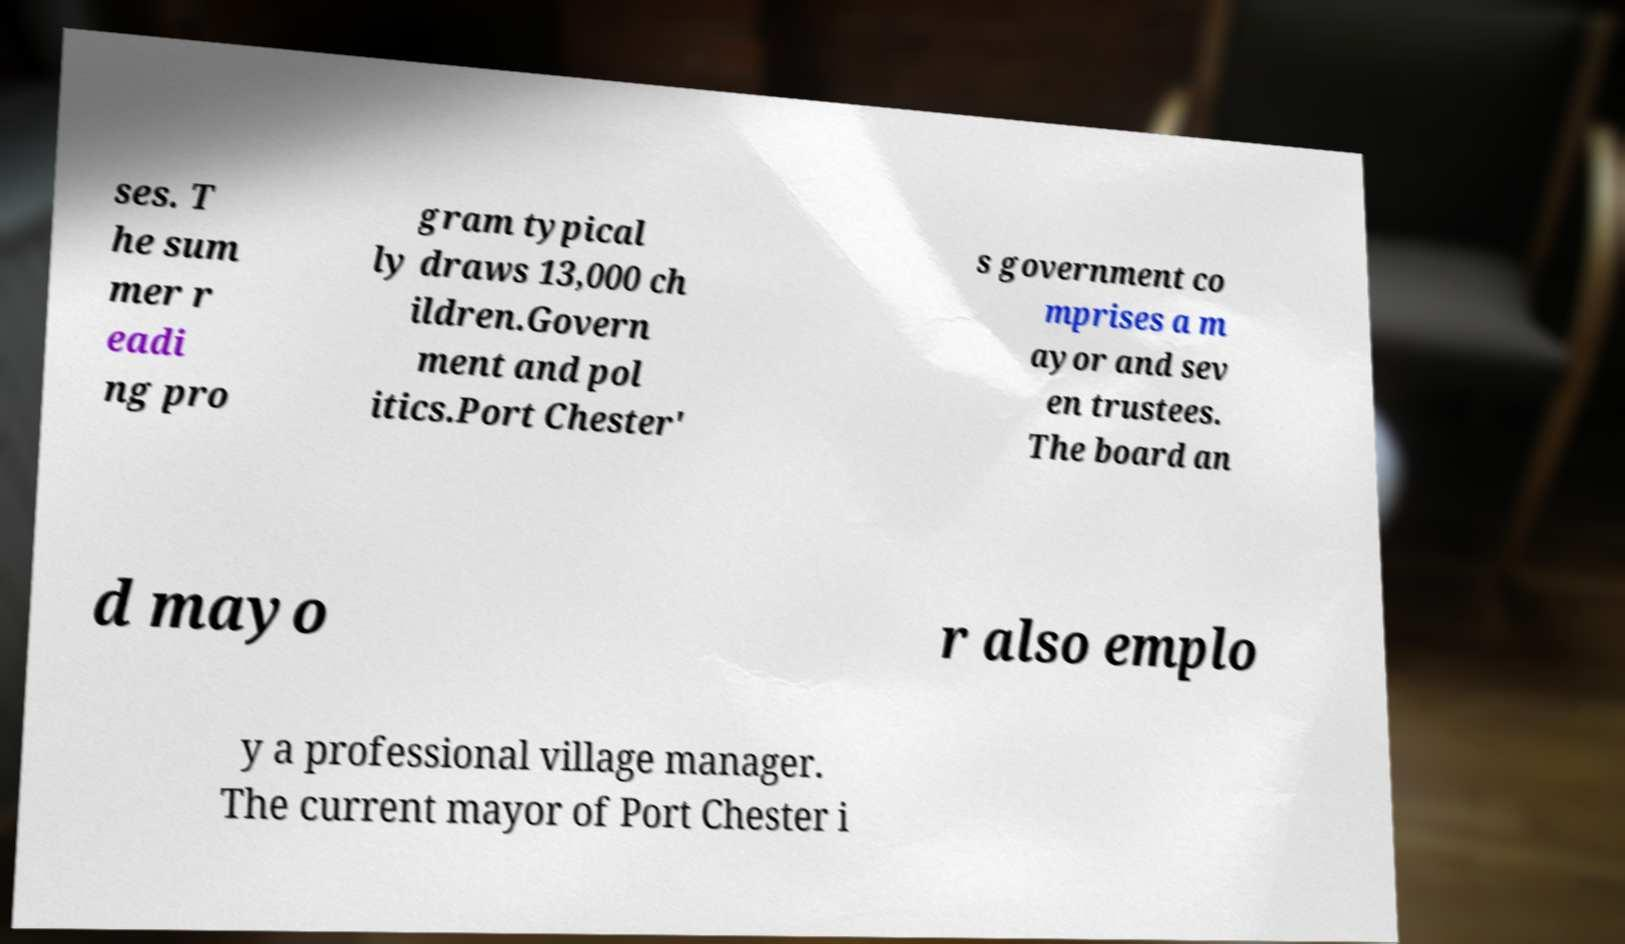For documentation purposes, I need the text within this image transcribed. Could you provide that? ses. T he sum mer r eadi ng pro gram typical ly draws 13,000 ch ildren.Govern ment and pol itics.Port Chester' s government co mprises a m ayor and sev en trustees. The board an d mayo r also emplo y a professional village manager. The current mayor of Port Chester i 